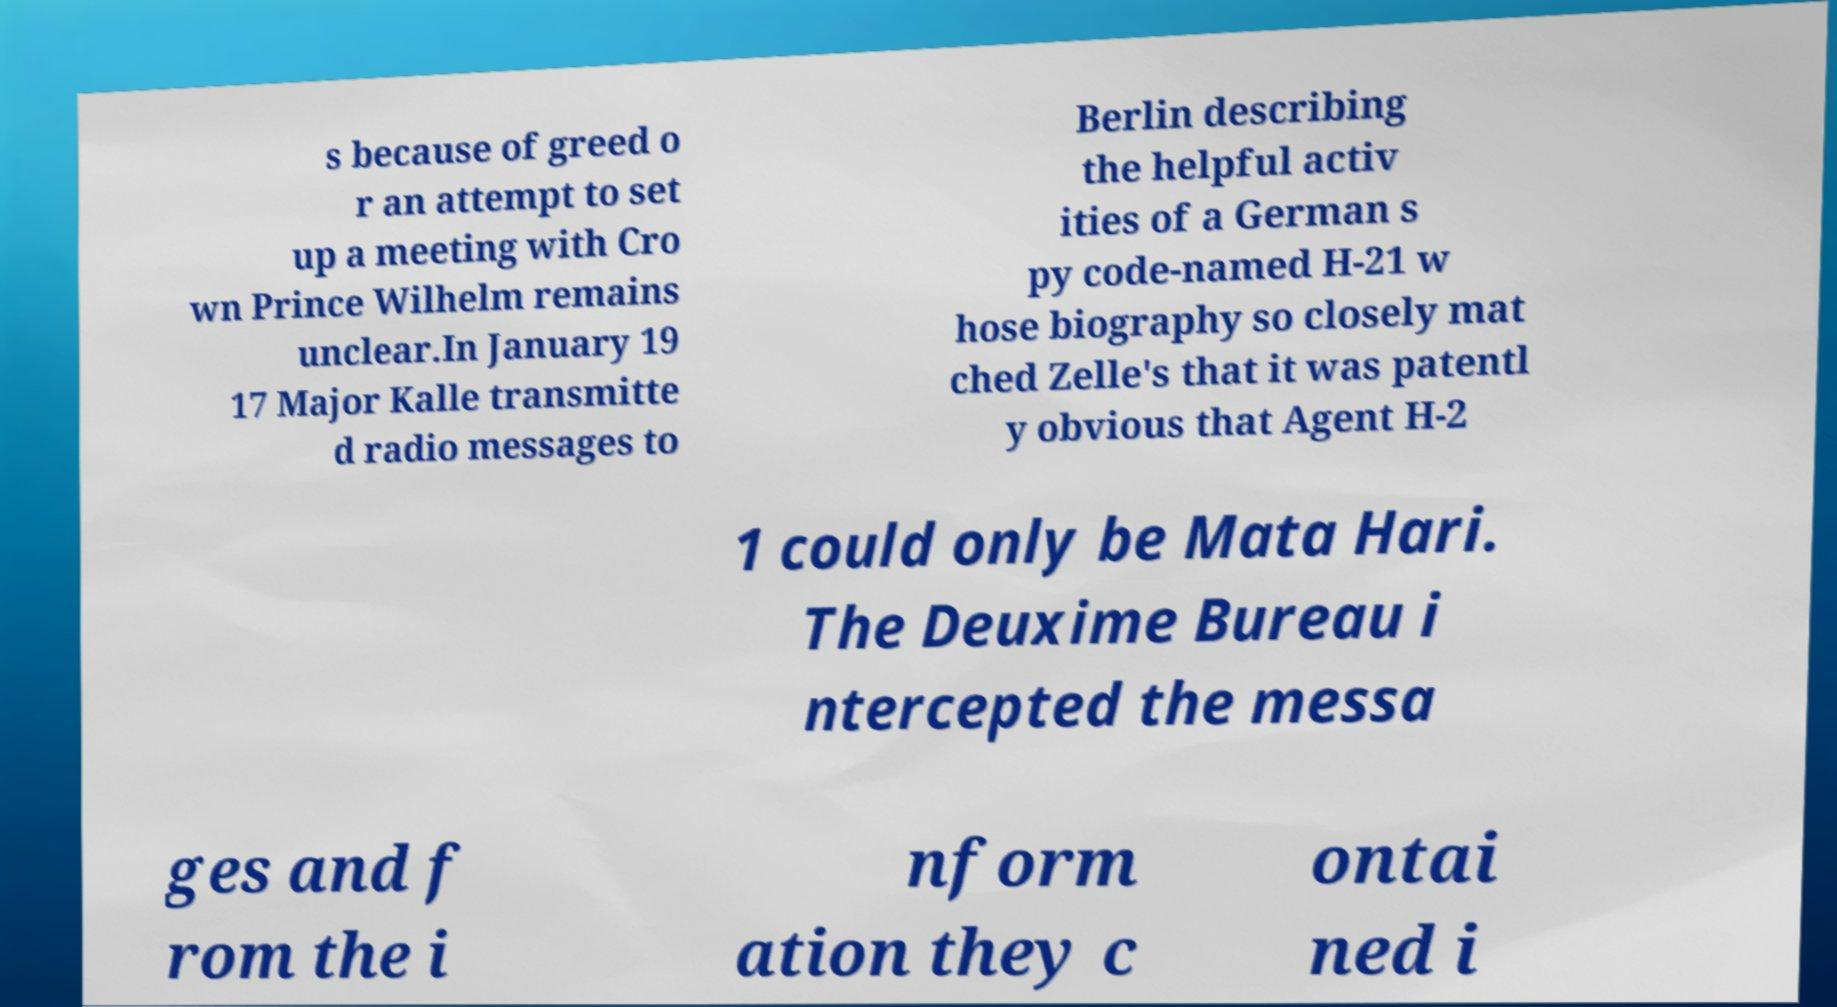For documentation purposes, I need the text within this image transcribed. Could you provide that? s because of greed o r an attempt to set up a meeting with Cro wn Prince Wilhelm remains unclear.In January 19 17 Major Kalle transmitte d radio messages to Berlin describing the helpful activ ities of a German s py code-named H-21 w hose biography so closely mat ched Zelle's that it was patentl y obvious that Agent H-2 1 could only be Mata Hari. The Deuxime Bureau i ntercepted the messa ges and f rom the i nform ation they c ontai ned i 